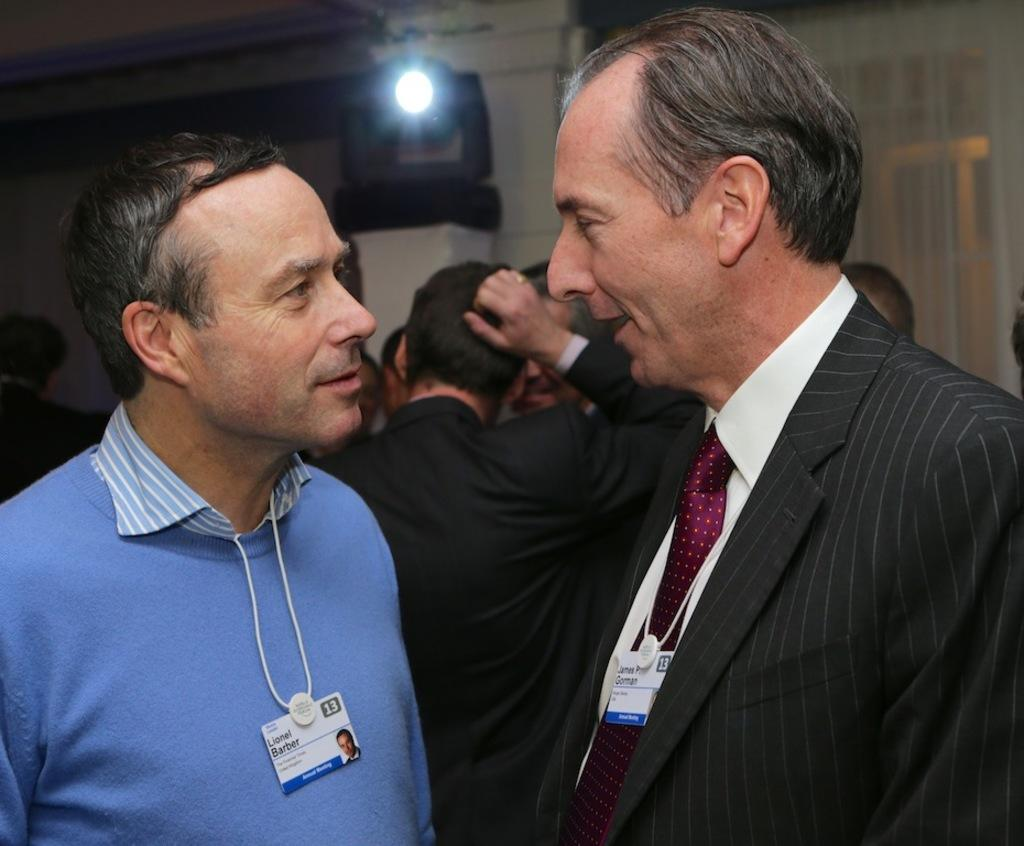Who or what can be seen in the image? There are people in the image. What is visible in the background of the image? There is a curtain, a light, and a wall in the background of the image. What type of leather is being used to write a letter in the image? There is no leather or letter-writing activity present in the image. 